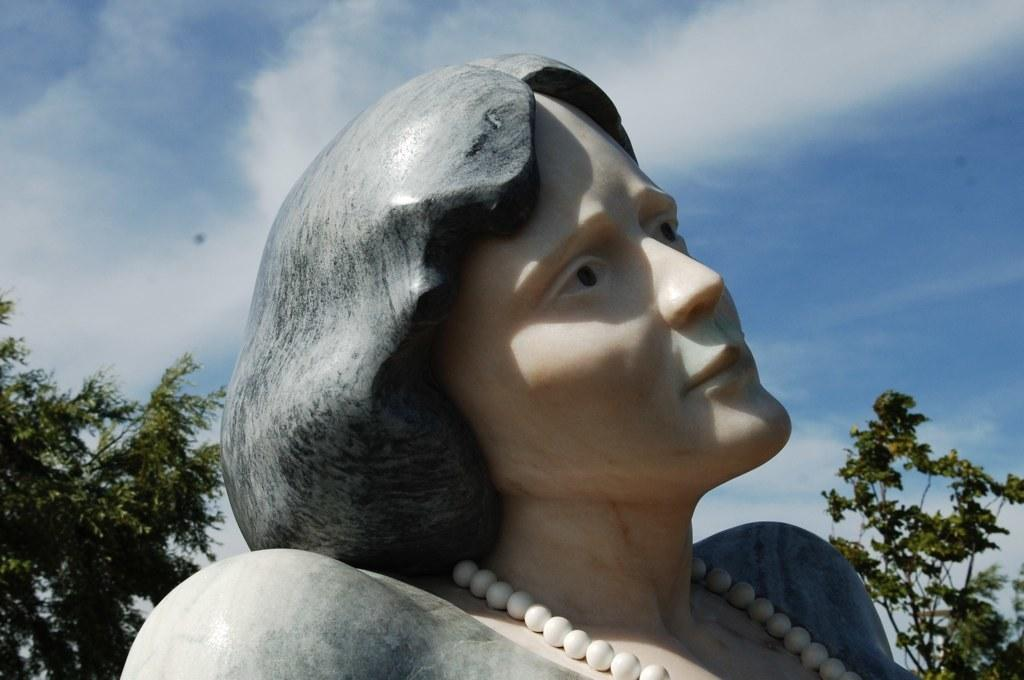What is the main subject of the image? There is a statue of a woman in the image. What type of natural elements can be seen in the image? There are trees visible in the image. How would you describe the weather based on the image? The sky is cloudy in the image, suggesting a potentially overcast or cloudy day. What type of jelly can be seen dripping from the statue's frame in the image? There is no jelly or frame present in the image; it features a statue of a woman and trees in a cloudy sky. 